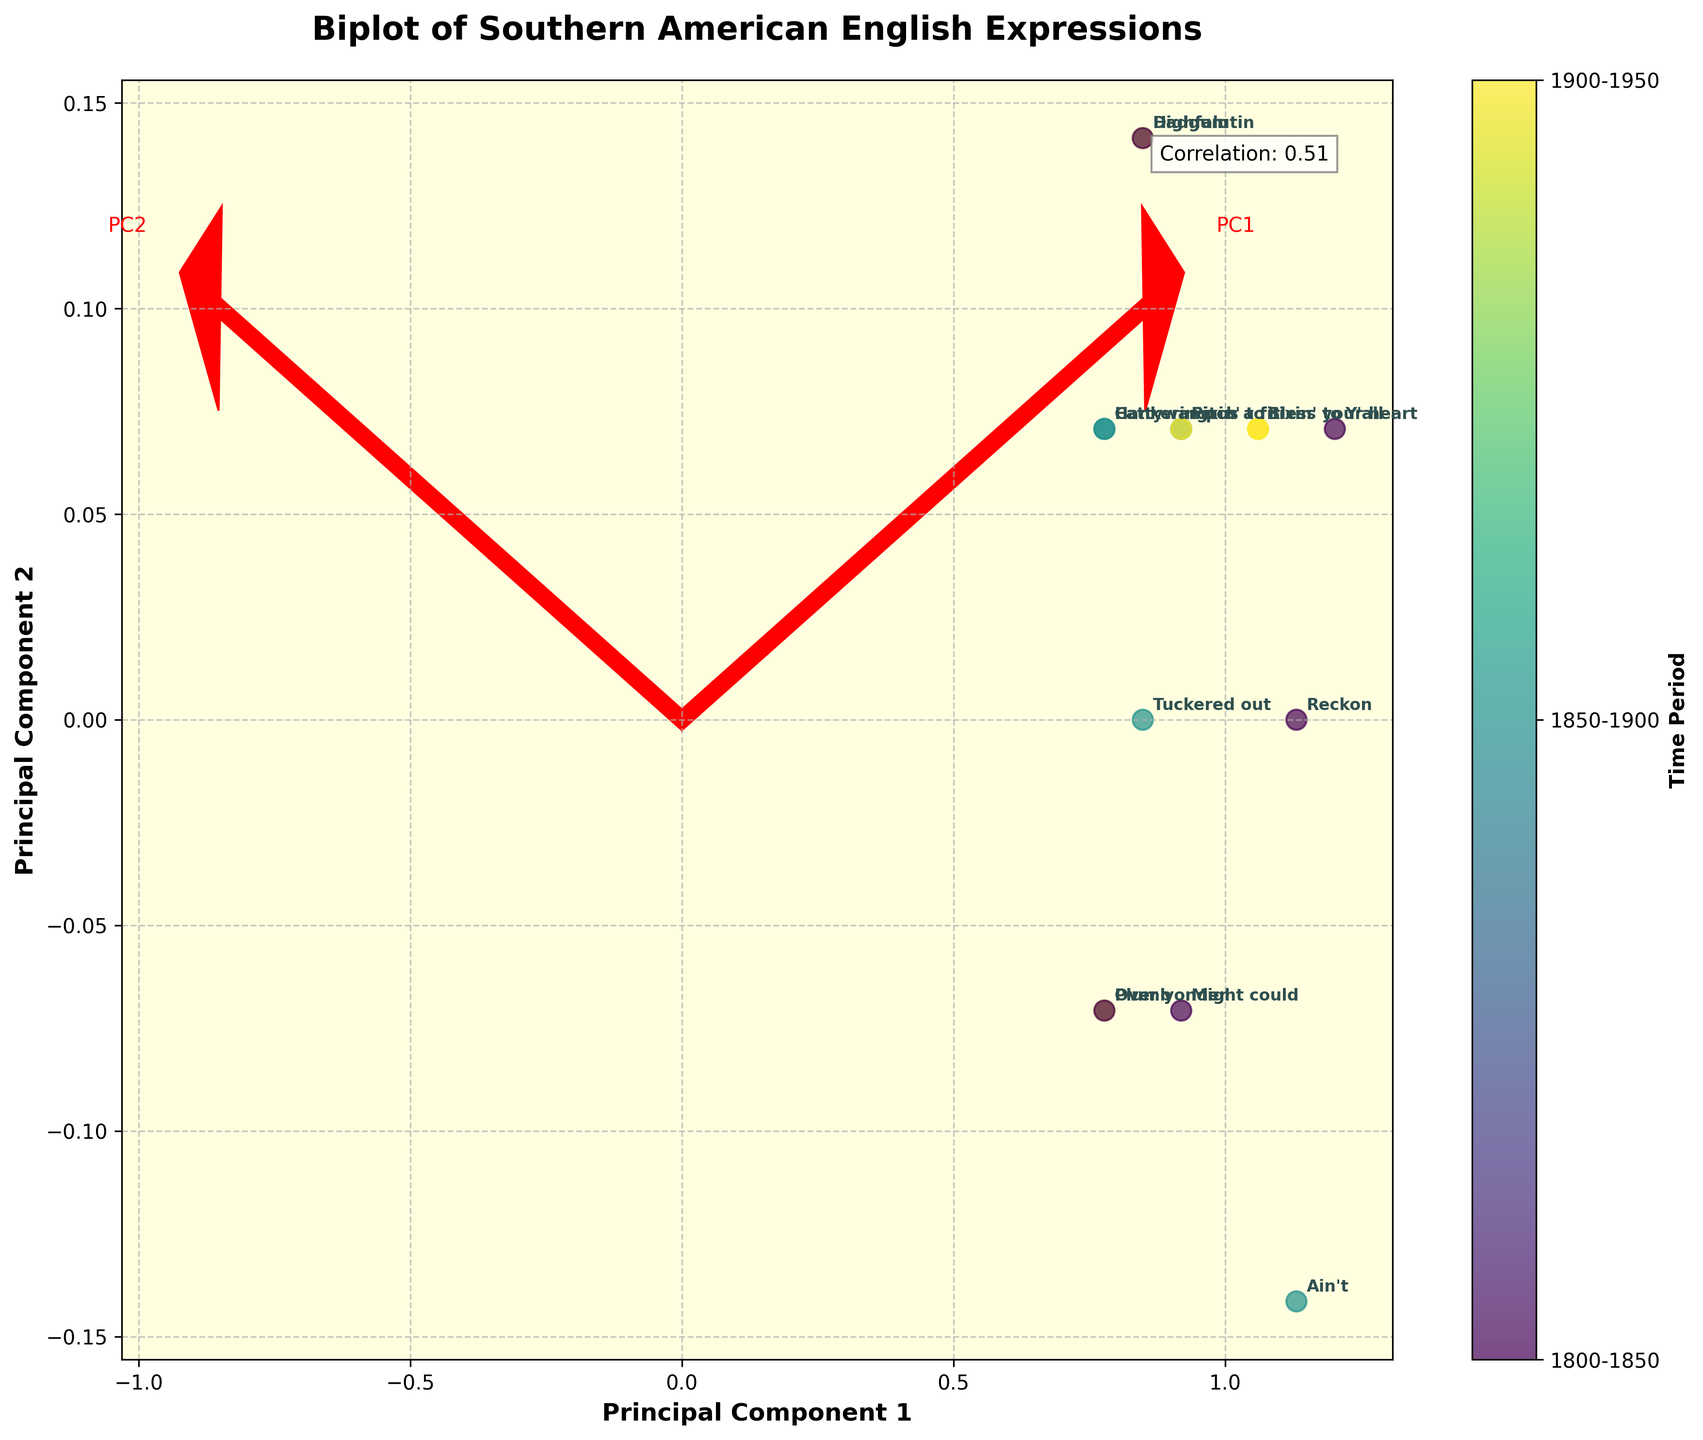What is the title of the plot? The title of the plot is displayed prominently at the top of the figure.
Answer: Biplot of Southern American English Expressions How many time periods are represented in the plot? The color bar on the side of the plot indicates three distinct time periods.
Answer: 3 Which expression has the highest frequency value on the plot? Identify the point with the highest value on the x-axis (Frequency) and check its associated label.
Answer: Ain't What is the correlation coefficient between Frequency and Cultural Impact, and what does it indicate? The correlation coefficient is shown in a text box within the plot. A high value close to 1 indicates a strong positive correlation.
Answer: 0.75 Which expression from the time period 1850-1900 has the lowest cultural impact? Identify points corresponding to the time period 1850-1900 (in the color bar), then find the one with the lowest y-value (Cultural Impact) and check its label.
Answer: Cattywampus How does the distribution of expressions in the Deep South compare across the time periods? Look at the color of points associated with the Deep South and note their spread across the plot according to the color bar.
Answer: Concentrated in 1800-1850 Which geographical area has the most diverse range of expressions in terms of time period? Identify the points and their colors (for different time periods) associated with each geographical area, then see which one covers the most colors.
Answer: Carolina Which principal component accounts for more variance and how can you tell? The biplot will show eigenvectors with different lengths representing principal components; the longer arrow indicates a higher explained variance.
Answer: PC1 Describe the trend in cultural impact for expressions in Georgia across the time periods. Locate the expressions from Georgia using their labels and colors, and compare their positions on the Cultural Impact axis.
Answer: Increased over time What does the direction of the first principal component (PC1) suggest about the relationship between Frequency and Cultural Impact? The direction of PC1 indicates the dominant axis; if it's close to the diagonal, it suggests that Frequency and Cultural Impact are positively correlated.
Answer: Positive correlation 